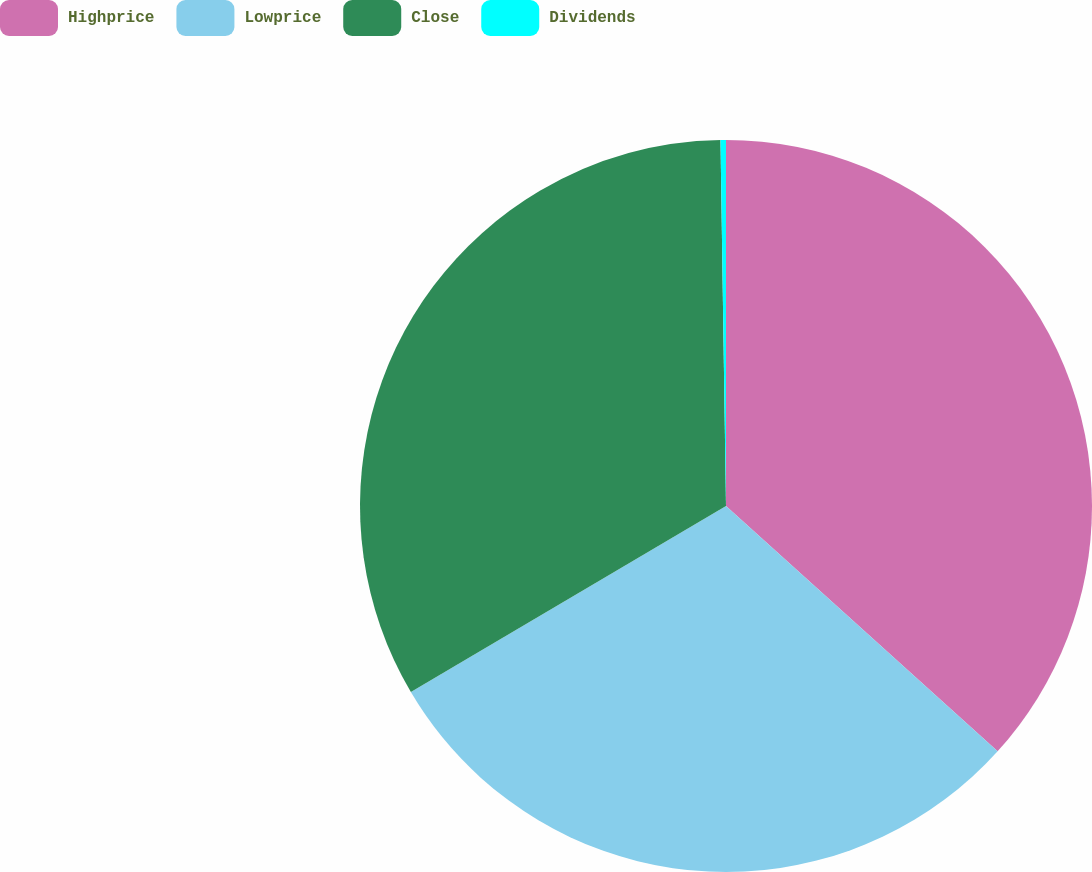Convert chart to OTSL. <chart><loc_0><loc_0><loc_500><loc_500><pie_chart><fcel>Highprice<fcel>Lowprice<fcel>Close<fcel>Dividends<nl><fcel>36.69%<fcel>29.82%<fcel>33.25%<fcel>0.24%<nl></chart> 